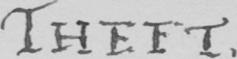Can you read and transcribe this handwriting? THEFT . 